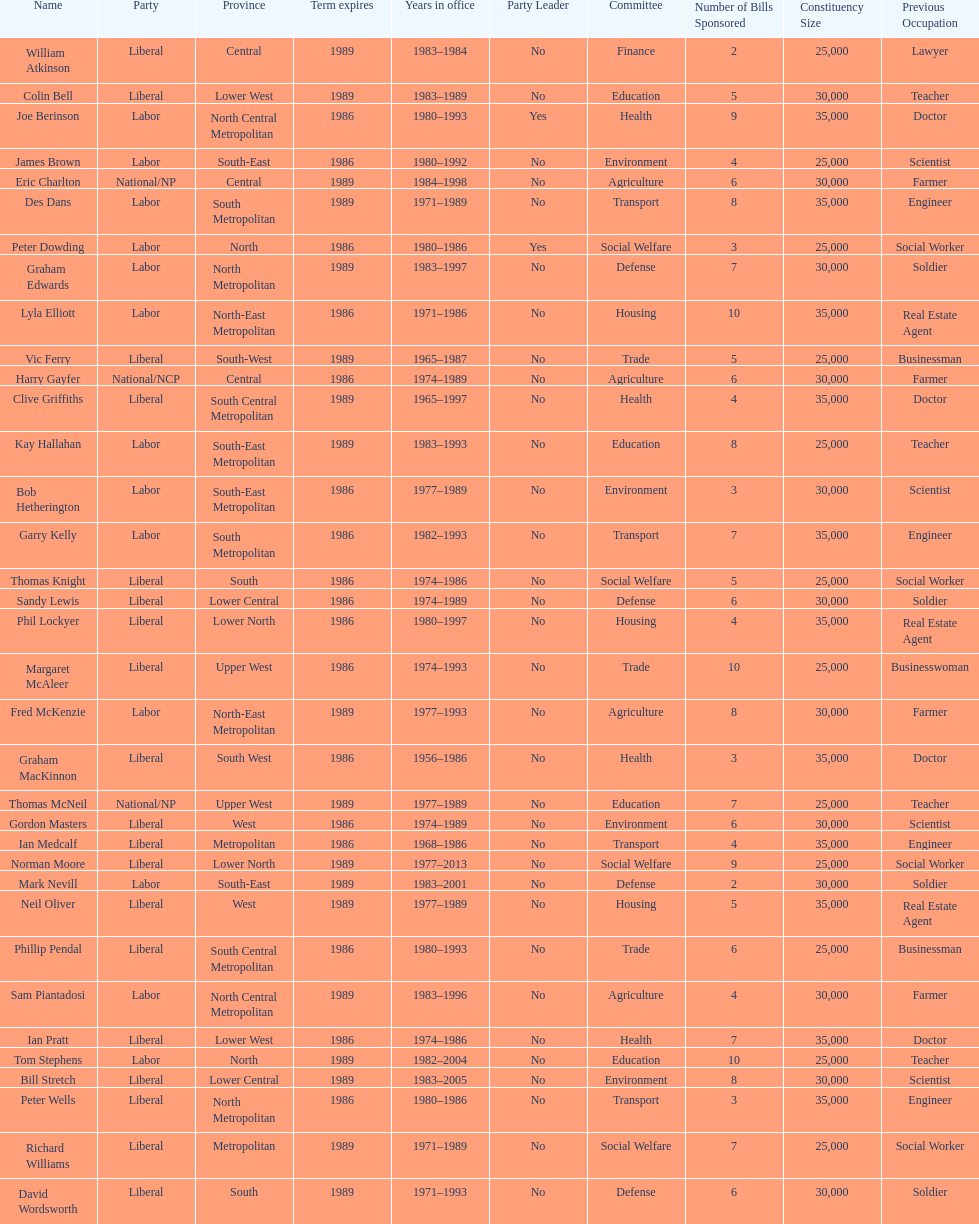What is the number of people in the liberal party? 19. 